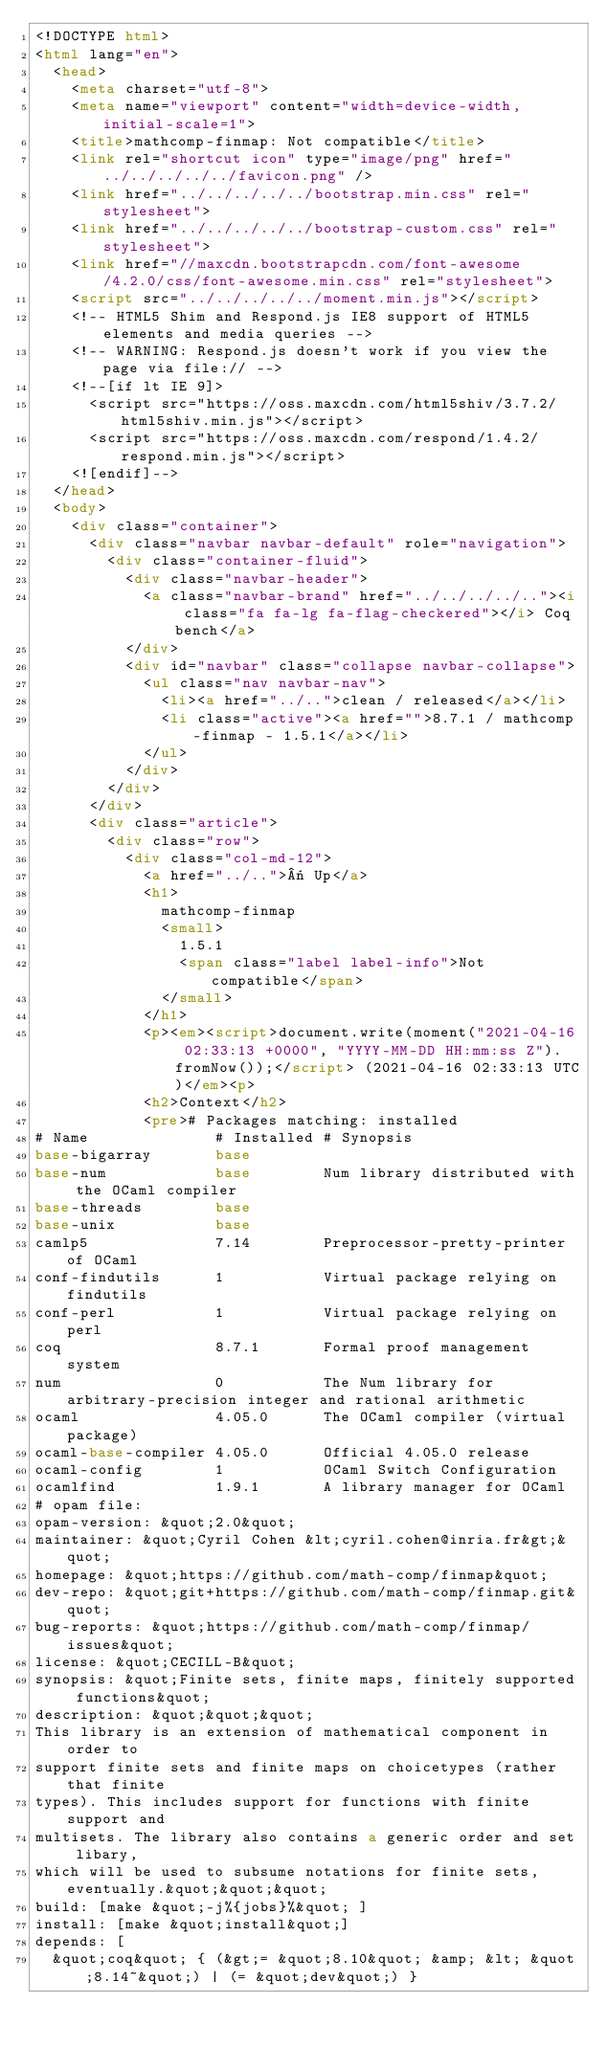<code> <loc_0><loc_0><loc_500><loc_500><_HTML_><!DOCTYPE html>
<html lang="en">
  <head>
    <meta charset="utf-8">
    <meta name="viewport" content="width=device-width, initial-scale=1">
    <title>mathcomp-finmap: Not compatible</title>
    <link rel="shortcut icon" type="image/png" href="../../../../../favicon.png" />
    <link href="../../../../../bootstrap.min.css" rel="stylesheet">
    <link href="../../../../../bootstrap-custom.css" rel="stylesheet">
    <link href="//maxcdn.bootstrapcdn.com/font-awesome/4.2.0/css/font-awesome.min.css" rel="stylesheet">
    <script src="../../../../../moment.min.js"></script>
    <!-- HTML5 Shim and Respond.js IE8 support of HTML5 elements and media queries -->
    <!-- WARNING: Respond.js doesn't work if you view the page via file:// -->
    <!--[if lt IE 9]>
      <script src="https://oss.maxcdn.com/html5shiv/3.7.2/html5shiv.min.js"></script>
      <script src="https://oss.maxcdn.com/respond/1.4.2/respond.min.js"></script>
    <![endif]-->
  </head>
  <body>
    <div class="container">
      <div class="navbar navbar-default" role="navigation">
        <div class="container-fluid">
          <div class="navbar-header">
            <a class="navbar-brand" href="../../../../.."><i class="fa fa-lg fa-flag-checkered"></i> Coq bench</a>
          </div>
          <div id="navbar" class="collapse navbar-collapse">
            <ul class="nav navbar-nav">
              <li><a href="../..">clean / released</a></li>
              <li class="active"><a href="">8.7.1 / mathcomp-finmap - 1.5.1</a></li>
            </ul>
          </div>
        </div>
      </div>
      <div class="article">
        <div class="row">
          <div class="col-md-12">
            <a href="../..">« Up</a>
            <h1>
              mathcomp-finmap
              <small>
                1.5.1
                <span class="label label-info">Not compatible</span>
              </small>
            </h1>
            <p><em><script>document.write(moment("2021-04-16 02:33:13 +0000", "YYYY-MM-DD HH:mm:ss Z").fromNow());</script> (2021-04-16 02:33:13 UTC)</em><p>
            <h2>Context</h2>
            <pre># Packages matching: installed
# Name              # Installed # Synopsis
base-bigarray       base
base-num            base        Num library distributed with the OCaml compiler
base-threads        base
base-unix           base
camlp5              7.14        Preprocessor-pretty-printer of OCaml
conf-findutils      1           Virtual package relying on findutils
conf-perl           1           Virtual package relying on perl
coq                 8.7.1       Formal proof management system
num                 0           The Num library for arbitrary-precision integer and rational arithmetic
ocaml               4.05.0      The OCaml compiler (virtual package)
ocaml-base-compiler 4.05.0      Official 4.05.0 release
ocaml-config        1           OCaml Switch Configuration
ocamlfind           1.9.1       A library manager for OCaml
# opam file:
opam-version: &quot;2.0&quot;
maintainer: &quot;Cyril Cohen &lt;cyril.cohen@inria.fr&gt;&quot;
homepage: &quot;https://github.com/math-comp/finmap&quot;
dev-repo: &quot;git+https://github.com/math-comp/finmap.git&quot;
bug-reports: &quot;https://github.com/math-comp/finmap/issues&quot;
license: &quot;CECILL-B&quot;
synopsis: &quot;Finite sets, finite maps, finitely supported functions&quot;
description: &quot;&quot;&quot;
This library is an extension of mathematical component in order to
support finite sets and finite maps on choicetypes (rather that finite
types). This includes support for functions with finite support and
multisets. The library also contains a generic order and set libary,
which will be used to subsume notations for finite sets, eventually.&quot;&quot;&quot;
build: [make &quot;-j%{jobs}%&quot; ]
install: [make &quot;install&quot;]
depends: [
  &quot;coq&quot; { (&gt;= &quot;8.10&quot; &amp; &lt; &quot;8.14~&quot;) | (= &quot;dev&quot;) }</code> 